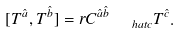<formula> <loc_0><loc_0><loc_500><loc_500>[ T ^ { \hat { a } } , T ^ { \hat { b } } ] = r C ^ { \hat { a } \hat { b } } _ { \quad h a t { c } } T ^ { \hat { c } } .</formula> 